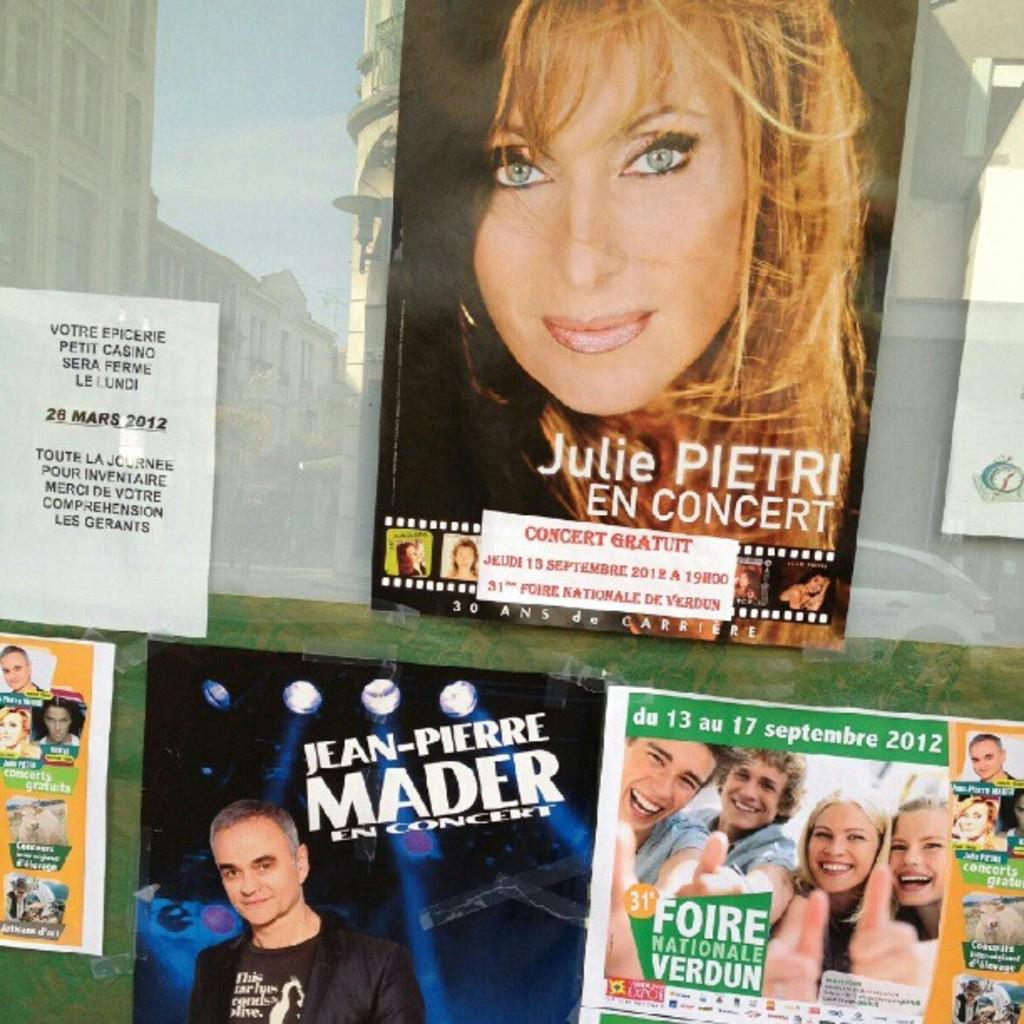What is displayed on the glass of the building in the image? There are posters on the glass of the building in the image. Can you describe the posters? The posters are visible in the image. What else can be seen on the glass in the image? There are reflections of buildings on the glass. Can you describe the reflections? The reflections are visible in the image. Is there a beggar holding a card in the image? No, there is no beggar or card present in the image. 